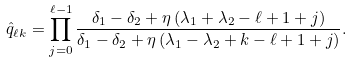<formula> <loc_0><loc_0><loc_500><loc_500>\hat { q } _ { \ell k } = \prod _ { j = 0 } ^ { \ell - 1 } \frac { \delta _ { 1 } - \delta _ { 2 } + \eta \, ( \lambda _ { 1 } + \lambda _ { 2 } - \ell + 1 + j ) } { \delta _ { 1 } - \delta _ { 2 } + \eta \, ( \lambda _ { 1 } - \lambda _ { 2 } + k - \ell + 1 + j ) } .</formula> 